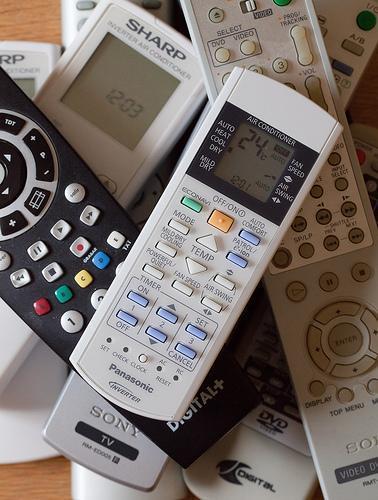How many black remotes are shown?
Give a very brief answer. 1. How many orange buttons are on the top remote?
Give a very brief answer. 1. How many blue buttons are on the panasonic remote?
Give a very brief answer. 8. How many black remotes are in the image?
Give a very brief answer. 1. 